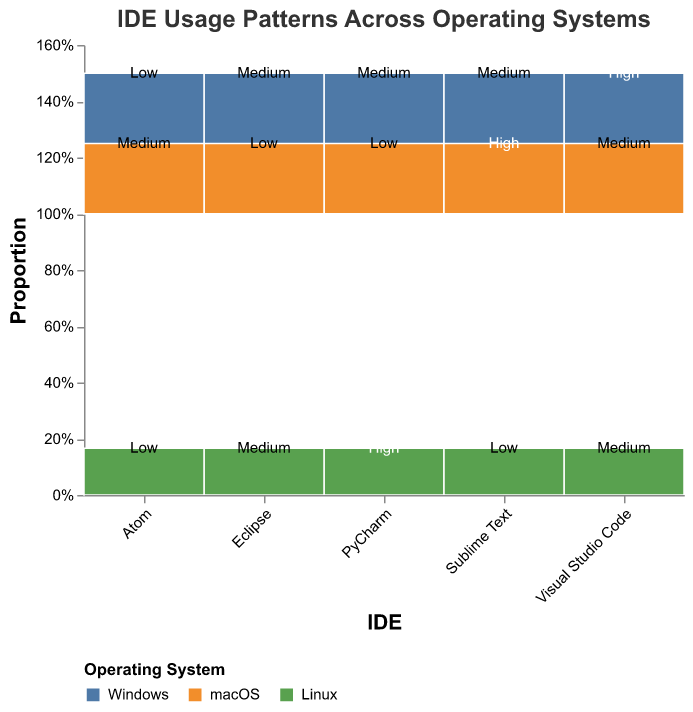What is the title of the mosaic plot? The title of the plot is displayed at the top and clearly states the subject of the visualization. "IDE Usage Patterns Across Operating Systems" is written in a larger font at the top of the figure.
Answer: IDE Usage Patterns Across Operating Systems Which operating system has the highest usage frequency for Visual Studio Code? Among the sections of Visual Studio Code represented in the plot, the "Windows" section is marked "High." Therefore, Windows has the highest usage frequency for Visual Studio Code.
Answer: Windows How does the usage frequency of PyCharm on macOS compare to its frequency on Linux? In the mosaic plot, the usage frequency of PyCharm on macOS is marked "Low" while on Linux it is marked "High." Comparing these frequencies, PyCharm is more frequently used on Linux than macOS.
Answer: Linux has higher usage frequency What proportion of IDEs have high usage on macOS? To determine the proportion of IDEs with high usage on macOS, we look at the sections with high usage on macOS. Only Sublime Text shows high usage. Given there are five IDEs, the proportion is 1/5.
Answer: 20% Which IDE shows equal usage frequency on both Windows and Linux? By observing the sections of each IDE, Eclipse is marked as "Medium" on both Windows and Linux, indicating equal usage frequency on these operating systems.
Answer: Eclipse Is there any IDE with low usage frequency on all operating systems? By scanning through each IDE's sections and their usage frequencies, Atom is the only IDE marked "Low" for both Windows and Linux, but it has "Medium" usage on macOS. Therefore, no IDE has low usage on all operating systems.
Answer: No What are the proportions of medium usage frequency for PyCharm across different operating systems? For PyCharm, the usages noted in the mosaic plot are "Medium" on Windows, "Low" on macOS, and "High" on Linux. Only Windows has a medium usage frequency. Since each IDE is represented equally in one-third sections for each OS, the proportion is 1/3.
Answer: One-third (33.33%) Which operating system shows the highest variety of usage frequencies across all IDEs? By analyzing the variety of usage frequencies for each operating system, macOS shows "Medium," "Low," and "High" frequencies, illustrating a wider variety of usage frequencies compared to others.
Answer: macOS Which IDE has the most balanced usage across all operating systems? To determine the most balanced usage, we can review the IDEs' usage frequencies across the operating systems. Visual Studio Code with "High" on Windows and "Medium" on both macOS and Linux seems the most balanced one.
Answer: Visual Studio Code How does the usage frequency of Eclipse on macOS compare to Atom on macOS? In the plot, Eclipse on macOS has a "Low" frequency, as does Atom on macOS. Therefore, the usage frequency of Eclipse on macOS is equal to that of Atom on macOS.
Answer: Equal 